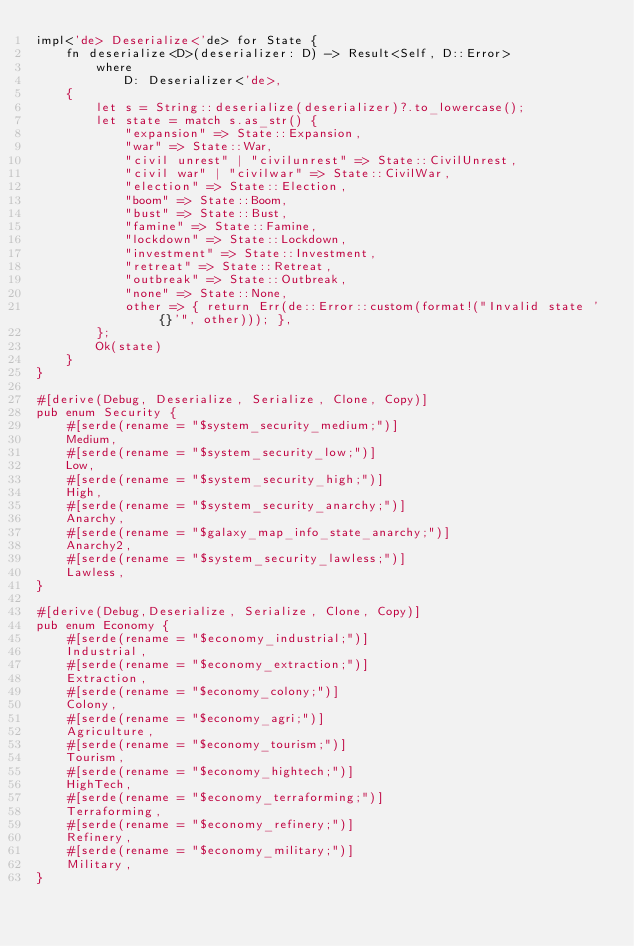<code> <loc_0><loc_0><loc_500><loc_500><_Rust_>impl<'de> Deserialize<'de> for State {
    fn deserialize<D>(deserializer: D) -> Result<Self, D::Error>
        where
            D: Deserializer<'de>,
    {
        let s = String::deserialize(deserializer)?.to_lowercase();
        let state = match s.as_str() {
            "expansion" => State::Expansion,
            "war" => State::War,
            "civil unrest" | "civilunrest" => State::CivilUnrest,
            "civil war" | "civilwar" => State::CivilWar,
            "election" => State::Election,
            "boom" => State::Boom,
            "bust" => State::Bust,
            "famine" => State::Famine,
            "lockdown" => State::Lockdown,
            "investment" => State::Investment,
            "retreat" => State::Retreat,
            "outbreak" => State::Outbreak,
            "none" => State::None,
            other => { return Err(de::Error::custom(format!("Invalid state '{}'", other))); },
        };
        Ok(state)
    }
}

#[derive(Debug, Deserialize, Serialize, Clone, Copy)]
pub enum Security {
    #[serde(rename = "$system_security_medium;")]
    Medium,
    #[serde(rename = "$system_security_low;")]
    Low,
    #[serde(rename = "$system_security_high;")]
    High,
    #[serde(rename = "$system_security_anarchy;")]
    Anarchy,
    #[serde(rename = "$galaxy_map_info_state_anarchy;")]
    Anarchy2,
    #[serde(rename = "$system_security_lawless;")]
    Lawless,
}

#[derive(Debug,Deserialize, Serialize, Clone, Copy)]
pub enum Economy {
    #[serde(rename = "$economy_industrial;")]
    Industrial,
    #[serde(rename = "$economy_extraction;")]
    Extraction,
    #[serde(rename = "$economy_colony;")]
    Colony,
    #[serde(rename = "$economy_agri;")]
    Agriculture,
    #[serde(rename = "$economy_tourism;")]
    Tourism,
    #[serde(rename = "$economy_hightech;")]
    HighTech,
    #[serde(rename = "$economy_terraforming;")]
    Terraforming,
    #[serde(rename = "$economy_refinery;")]
    Refinery,
    #[serde(rename = "$economy_military;")]
    Military,
}</code> 